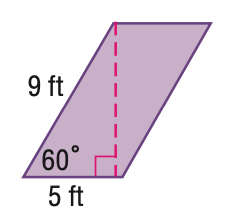Answer the mathemtical geometry problem and directly provide the correct option letter.
Question: Find the perimeter of the parallelogram. Round to the nearest tenth if necessary.
Choices: A: 14 B: 20 C: 28 D: 36 C 